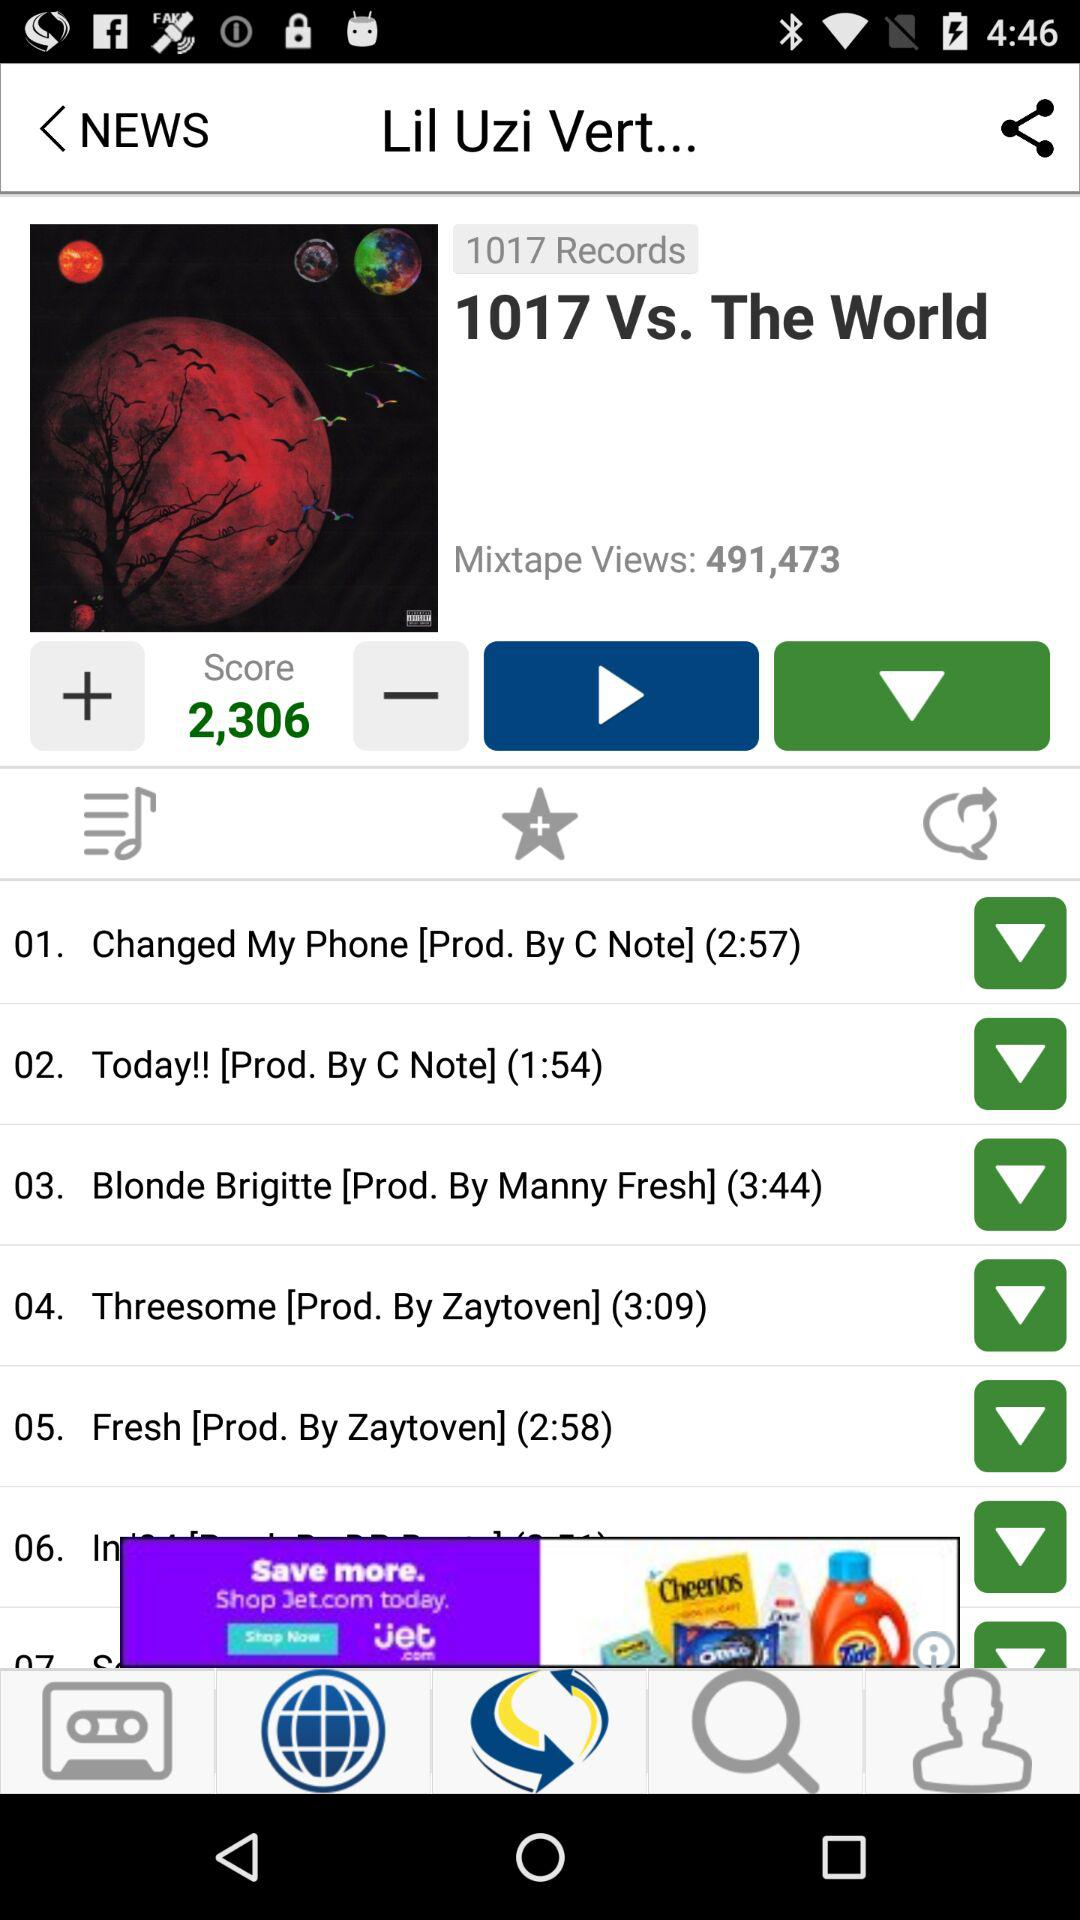How many songs are on this mixtape?
Answer the question using a single word or phrase. 7 